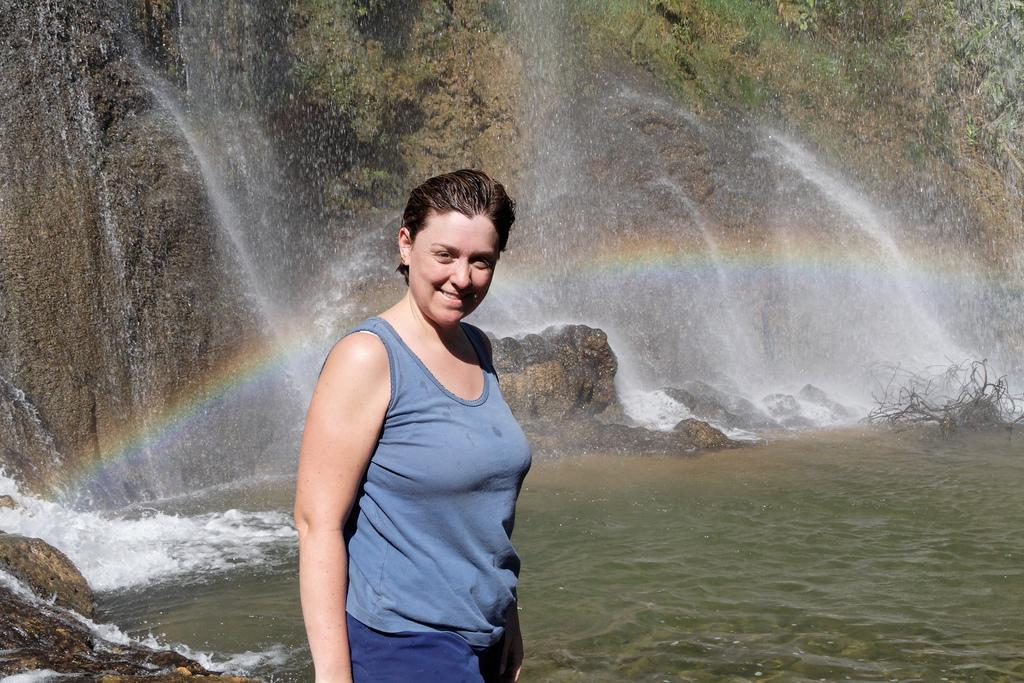Who is the main subject in the image? There is a woman standing in the middle of the image. What is the woman doing in the image? The woman is smiling. What can be seen in the background of the image? There is a hill and a waterfall in the background of the image. What is the primary natural element visible in the image? Water is visible in the image. How many birds are perched on the woman's shoulder in the image? There are no birds present in the image. What type of frogs can be seen hopping near the waterfall in the image? There are no frogs present in the image. 